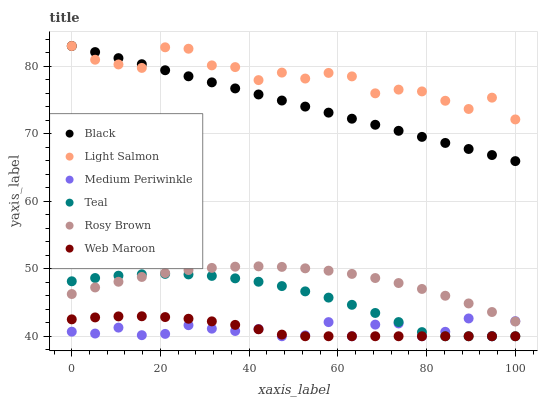Does Medium Periwinkle have the minimum area under the curve?
Answer yes or no. Yes. Does Light Salmon have the maximum area under the curve?
Answer yes or no. Yes. Does Rosy Brown have the minimum area under the curve?
Answer yes or no. No. Does Rosy Brown have the maximum area under the curve?
Answer yes or no. No. Is Black the smoothest?
Answer yes or no. Yes. Is Light Salmon the roughest?
Answer yes or no. Yes. Is Medium Periwinkle the smoothest?
Answer yes or no. No. Is Medium Periwinkle the roughest?
Answer yes or no. No. Does Medium Periwinkle have the lowest value?
Answer yes or no. Yes. Does Rosy Brown have the lowest value?
Answer yes or no. No. Does Black have the highest value?
Answer yes or no. Yes. Does Rosy Brown have the highest value?
Answer yes or no. No. Is Teal less than Light Salmon?
Answer yes or no. Yes. Is Light Salmon greater than Web Maroon?
Answer yes or no. Yes. Does Teal intersect Medium Periwinkle?
Answer yes or no. Yes. Is Teal less than Medium Periwinkle?
Answer yes or no. No. Is Teal greater than Medium Periwinkle?
Answer yes or no. No. Does Teal intersect Light Salmon?
Answer yes or no. No. 